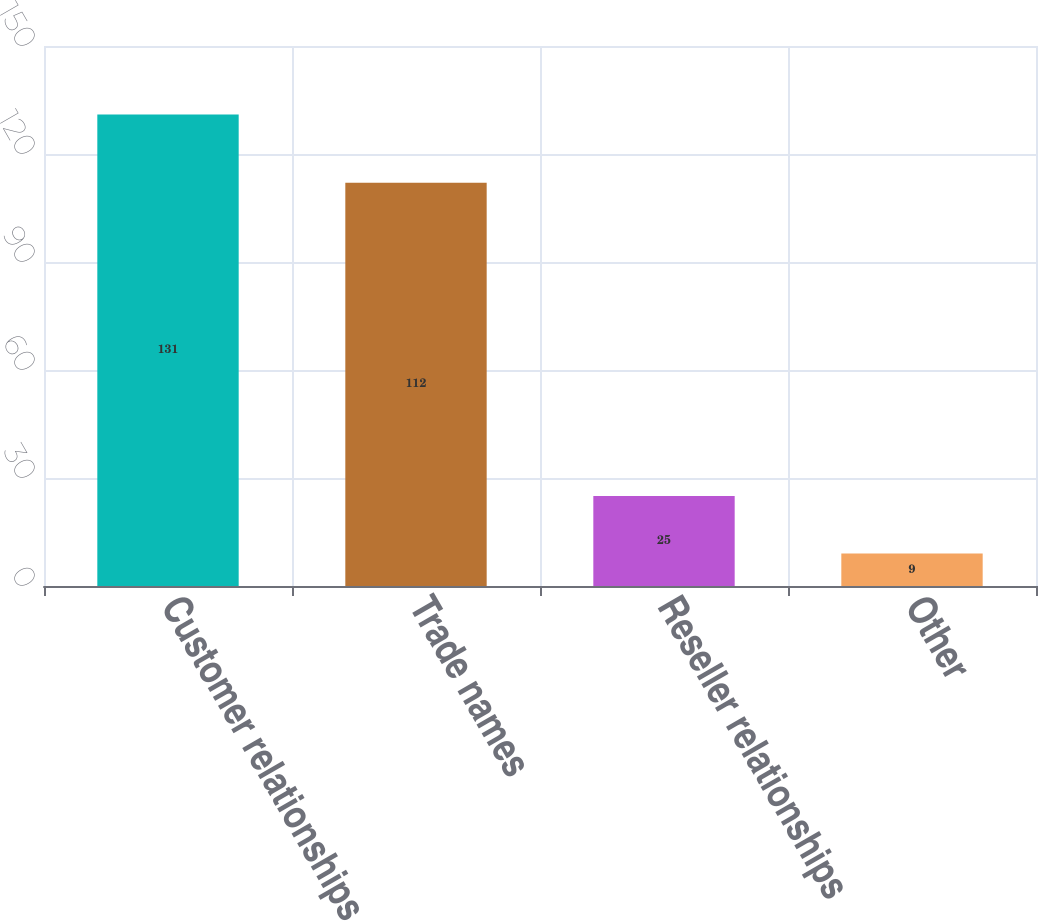Convert chart to OTSL. <chart><loc_0><loc_0><loc_500><loc_500><bar_chart><fcel>Customer relationships<fcel>Trade names<fcel>Reseller relationships<fcel>Other<nl><fcel>131<fcel>112<fcel>25<fcel>9<nl></chart> 